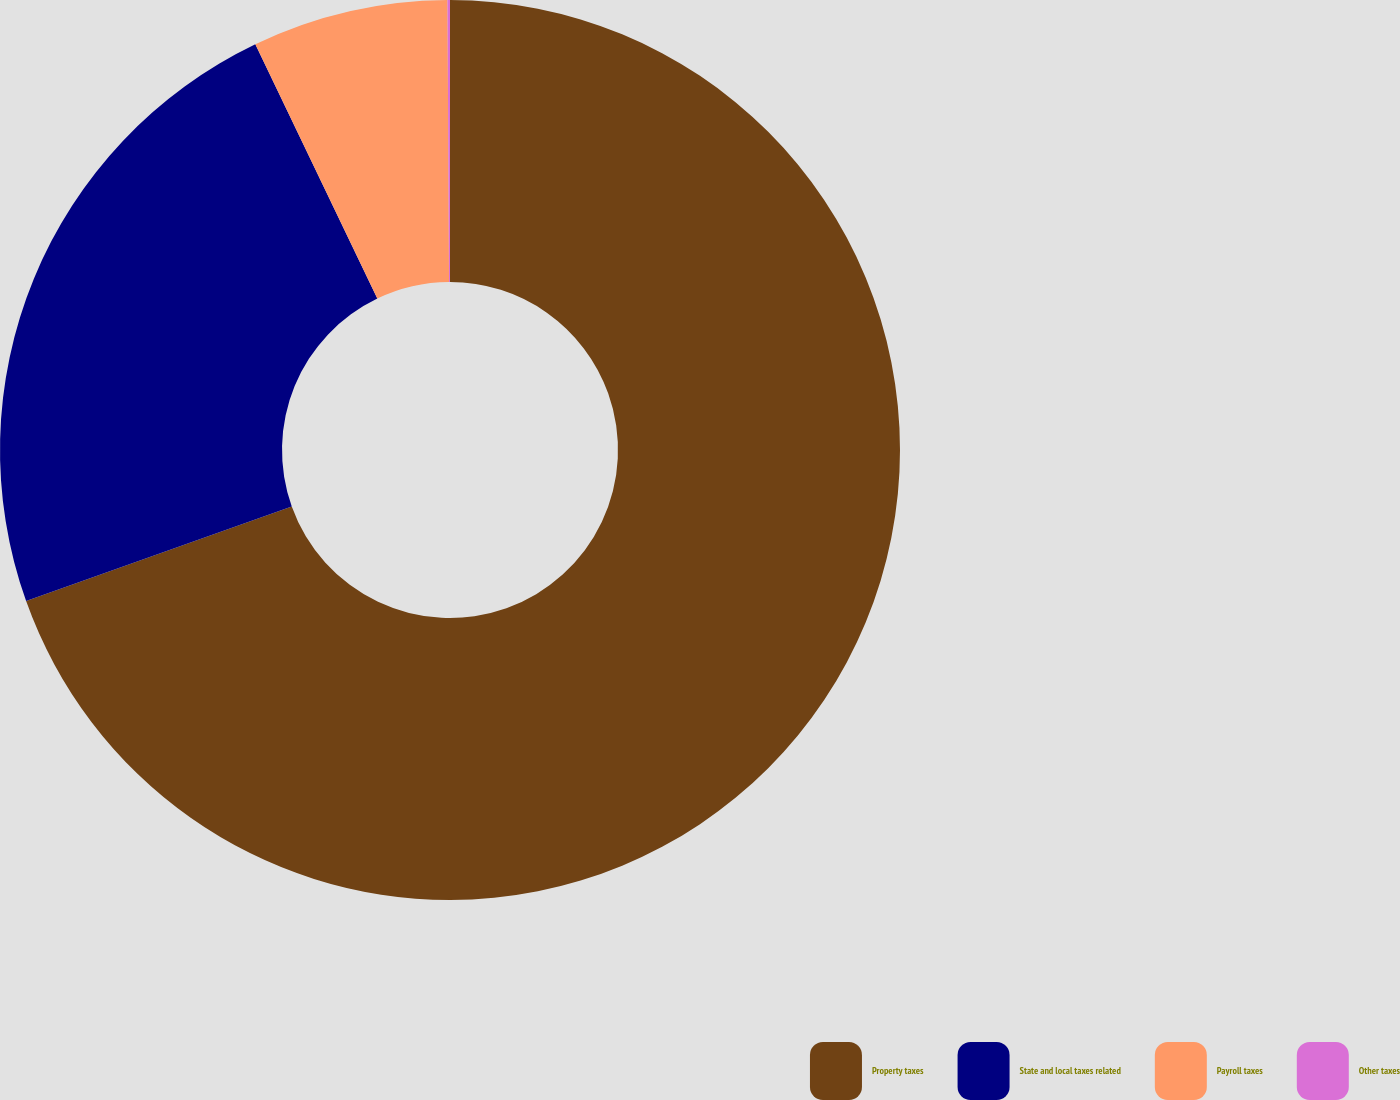<chart> <loc_0><loc_0><loc_500><loc_500><pie_chart><fcel>Property taxes<fcel>State and local taxes related<fcel>Payroll taxes<fcel>Other taxes<nl><fcel>69.55%<fcel>23.33%<fcel>7.03%<fcel>0.09%<nl></chart> 